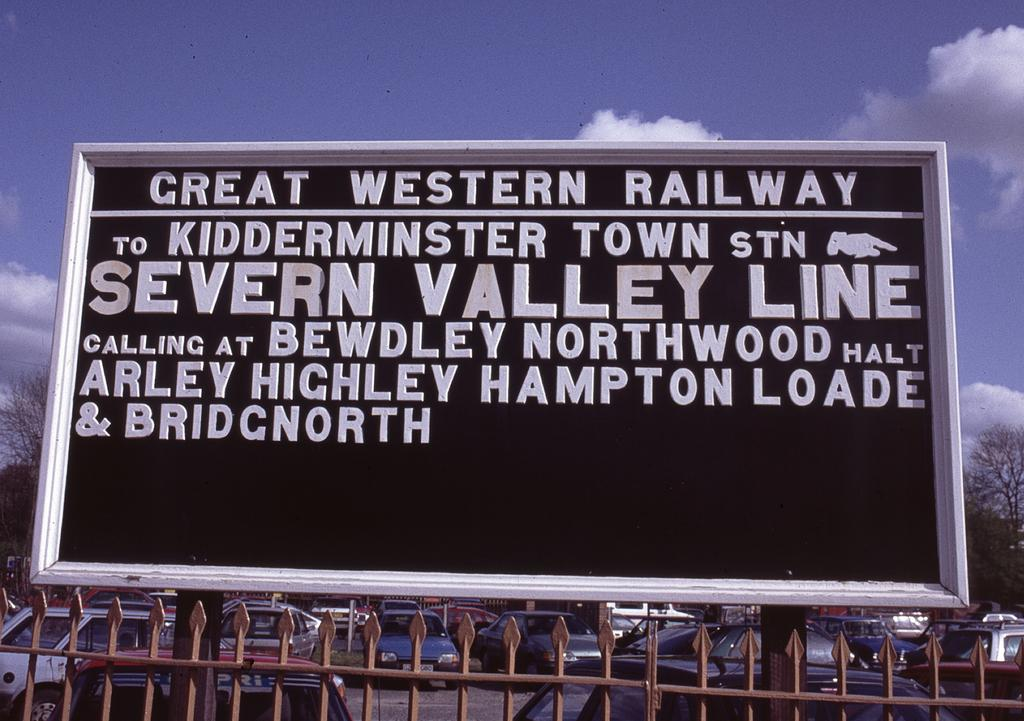<image>
Present a compact description of the photo's key features. A black and white sign for the Severn Valley Line of the Great Western Railway hangs above a spiked fence. 